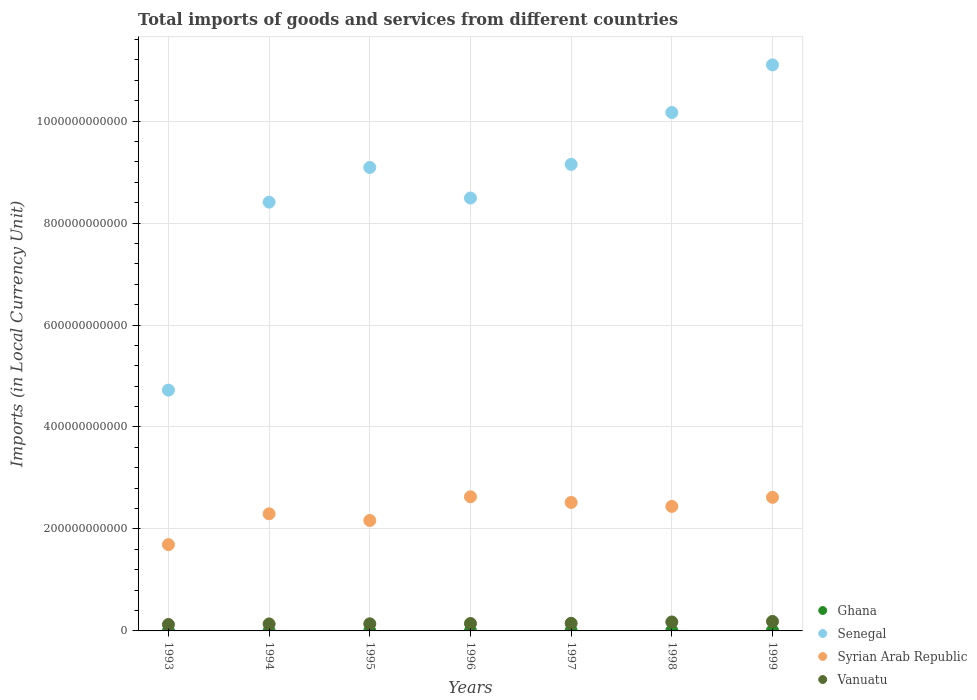Is the number of dotlines equal to the number of legend labels?
Your answer should be very brief. Yes. What is the Amount of goods and services imports in Ghana in 1998?
Provide a succinct answer. 8.08e+08. Across all years, what is the maximum Amount of goods and services imports in Ghana?
Offer a very short reply. 1.02e+09. Across all years, what is the minimum Amount of goods and services imports in Ghana?
Your response must be concise. 1.41e+08. In which year was the Amount of goods and services imports in Senegal maximum?
Your response must be concise. 1999. In which year was the Amount of goods and services imports in Vanuatu minimum?
Your answer should be compact. 1993. What is the total Amount of goods and services imports in Ghana in the graph?
Offer a very short reply. 3.62e+09. What is the difference between the Amount of goods and services imports in Vanuatu in 1994 and that in 1998?
Your answer should be very brief. -3.84e+09. What is the difference between the Amount of goods and services imports in Syrian Arab Republic in 1993 and the Amount of goods and services imports in Vanuatu in 1998?
Keep it short and to the point. 1.52e+11. What is the average Amount of goods and services imports in Syrian Arab Republic per year?
Offer a terse response. 2.34e+11. In the year 1996, what is the difference between the Amount of goods and services imports in Ghana and Amount of goods and services imports in Senegal?
Offer a very short reply. -8.49e+11. What is the ratio of the Amount of goods and services imports in Syrian Arab Republic in 1993 to that in 1997?
Provide a succinct answer. 0.67. What is the difference between the highest and the second highest Amount of goods and services imports in Ghana?
Keep it short and to the point. 2.13e+08. What is the difference between the highest and the lowest Amount of goods and services imports in Ghana?
Your answer should be compact. 8.80e+08. In how many years, is the Amount of goods and services imports in Ghana greater than the average Amount of goods and services imports in Ghana taken over all years?
Offer a terse response. 3. Is the sum of the Amount of goods and services imports in Vanuatu in 1993 and 1994 greater than the maximum Amount of goods and services imports in Senegal across all years?
Your answer should be compact. No. Is it the case that in every year, the sum of the Amount of goods and services imports in Syrian Arab Republic and Amount of goods and services imports in Vanuatu  is greater than the sum of Amount of goods and services imports in Senegal and Amount of goods and services imports in Ghana?
Offer a terse response. No. Does the Amount of goods and services imports in Ghana monotonically increase over the years?
Provide a succinct answer. Yes. Is the Amount of goods and services imports in Senegal strictly greater than the Amount of goods and services imports in Ghana over the years?
Provide a short and direct response. Yes. Is the Amount of goods and services imports in Ghana strictly less than the Amount of goods and services imports in Vanuatu over the years?
Provide a short and direct response. Yes. How many years are there in the graph?
Make the answer very short. 7. What is the difference between two consecutive major ticks on the Y-axis?
Your answer should be very brief. 2.00e+11. Does the graph contain grids?
Your answer should be very brief. Yes. How are the legend labels stacked?
Give a very brief answer. Vertical. What is the title of the graph?
Make the answer very short. Total imports of goods and services from different countries. Does "Congo (Democratic)" appear as one of the legend labels in the graph?
Your answer should be compact. No. What is the label or title of the X-axis?
Keep it short and to the point. Years. What is the label or title of the Y-axis?
Your answer should be very brief. Imports (in Local Currency Unit). What is the Imports (in Local Currency Unit) of Ghana in 1993?
Make the answer very short. 1.41e+08. What is the Imports (in Local Currency Unit) of Senegal in 1993?
Provide a short and direct response. 4.72e+11. What is the Imports (in Local Currency Unit) in Syrian Arab Republic in 1993?
Your response must be concise. 1.69e+11. What is the Imports (in Local Currency Unit) in Vanuatu in 1993?
Offer a very short reply. 1.26e+1. What is the Imports (in Local Currency Unit) in Ghana in 1994?
Ensure brevity in your answer.  1.91e+08. What is the Imports (in Local Currency Unit) of Senegal in 1994?
Give a very brief answer. 8.41e+11. What is the Imports (in Local Currency Unit) of Syrian Arab Republic in 1994?
Give a very brief answer. 2.30e+11. What is the Imports (in Local Currency Unit) of Vanuatu in 1994?
Give a very brief answer. 1.37e+1. What is the Imports (in Local Currency Unit) in Ghana in 1995?
Your answer should be very brief. 2.55e+08. What is the Imports (in Local Currency Unit) of Senegal in 1995?
Ensure brevity in your answer.  9.09e+11. What is the Imports (in Local Currency Unit) in Syrian Arab Republic in 1995?
Provide a succinct answer. 2.17e+11. What is the Imports (in Local Currency Unit) in Vanuatu in 1995?
Your response must be concise. 1.40e+1. What is the Imports (in Local Currency Unit) in Ghana in 1996?
Provide a short and direct response. 4.55e+08. What is the Imports (in Local Currency Unit) of Senegal in 1996?
Offer a terse response. 8.49e+11. What is the Imports (in Local Currency Unit) of Syrian Arab Republic in 1996?
Keep it short and to the point. 2.63e+11. What is the Imports (in Local Currency Unit) of Vanuatu in 1996?
Offer a terse response. 1.46e+1. What is the Imports (in Local Currency Unit) in Ghana in 1997?
Offer a very short reply. 7.48e+08. What is the Imports (in Local Currency Unit) of Senegal in 1997?
Provide a short and direct response. 9.15e+11. What is the Imports (in Local Currency Unit) in Syrian Arab Republic in 1997?
Your answer should be compact. 2.52e+11. What is the Imports (in Local Currency Unit) of Vanuatu in 1997?
Offer a very short reply. 1.49e+1. What is the Imports (in Local Currency Unit) in Ghana in 1998?
Offer a very short reply. 8.08e+08. What is the Imports (in Local Currency Unit) in Senegal in 1998?
Your answer should be very brief. 1.02e+12. What is the Imports (in Local Currency Unit) in Syrian Arab Republic in 1998?
Keep it short and to the point. 2.44e+11. What is the Imports (in Local Currency Unit) in Vanuatu in 1998?
Give a very brief answer. 1.75e+1. What is the Imports (in Local Currency Unit) of Ghana in 1999?
Give a very brief answer. 1.02e+09. What is the Imports (in Local Currency Unit) in Senegal in 1999?
Keep it short and to the point. 1.11e+12. What is the Imports (in Local Currency Unit) of Syrian Arab Republic in 1999?
Your answer should be compact. 2.62e+11. What is the Imports (in Local Currency Unit) of Vanuatu in 1999?
Your answer should be compact. 1.86e+1. Across all years, what is the maximum Imports (in Local Currency Unit) of Ghana?
Ensure brevity in your answer.  1.02e+09. Across all years, what is the maximum Imports (in Local Currency Unit) of Senegal?
Your response must be concise. 1.11e+12. Across all years, what is the maximum Imports (in Local Currency Unit) of Syrian Arab Republic?
Provide a succinct answer. 2.63e+11. Across all years, what is the maximum Imports (in Local Currency Unit) of Vanuatu?
Offer a terse response. 1.86e+1. Across all years, what is the minimum Imports (in Local Currency Unit) of Ghana?
Provide a short and direct response. 1.41e+08. Across all years, what is the minimum Imports (in Local Currency Unit) of Senegal?
Provide a succinct answer. 4.72e+11. Across all years, what is the minimum Imports (in Local Currency Unit) in Syrian Arab Republic?
Your response must be concise. 1.69e+11. Across all years, what is the minimum Imports (in Local Currency Unit) of Vanuatu?
Give a very brief answer. 1.26e+1. What is the total Imports (in Local Currency Unit) of Ghana in the graph?
Provide a short and direct response. 3.62e+09. What is the total Imports (in Local Currency Unit) in Senegal in the graph?
Ensure brevity in your answer.  6.11e+12. What is the total Imports (in Local Currency Unit) in Syrian Arab Republic in the graph?
Provide a short and direct response. 1.64e+12. What is the total Imports (in Local Currency Unit) in Vanuatu in the graph?
Give a very brief answer. 1.06e+11. What is the difference between the Imports (in Local Currency Unit) in Ghana in 1993 and that in 1994?
Provide a succinct answer. -5.03e+07. What is the difference between the Imports (in Local Currency Unit) in Senegal in 1993 and that in 1994?
Your answer should be very brief. -3.69e+11. What is the difference between the Imports (in Local Currency Unit) of Syrian Arab Republic in 1993 and that in 1994?
Offer a very short reply. -6.05e+1. What is the difference between the Imports (in Local Currency Unit) of Vanuatu in 1993 and that in 1994?
Your response must be concise. -1.07e+09. What is the difference between the Imports (in Local Currency Unit) in Ghana in 1993 and that in 1995?
Offer a very short reply. -1.14e+08. What is the difference between the Imports (in Local Currency Unit) in Senegal in 1993 and that in 1995?
Give a very brief answer. -4.37e+11. What is the difference between the Imports (in Local Currency Unit) of Syrian Arab Republic in 1993 and that in 1995?
Offer a very short reply. -4.74e+1. What is the difference between the Imports (in Local Currency Unit) of Vanuatu in 1993 and that in 1995?
Make the answer very short. -1.37e+09. What is the difference between the Imports (in Local Currency Unit) in Ghana in 1993 and that in 1996?
Make the answer very short. -3.14e+08. What is the difference between the Imports (in Local Currency Unit) in Senegal in 1993 and that in 1996?
Give a very brief answer. -3.77e+11. What is the difference between the Imports (in Local Currency Unit) in Syrian Arab Republic in 1993 and that in 1996?
Your response must be concise. -9.39e+1. What is the difference between the Imports (in Local Currency Unit) in Vanuatu in 1993 and that in 1996?
Ensure brevity in your answer.  -1.92e+09. What is the difference between the Imports (in Local Currency Unit) of Ghana in 1993 and that in 1997?
Your answer should be very brief. -6.07e+08. What is the difference between the Imports (in Local Currency Unit) of Senegal in 1993 and that in 1997?
Offer a terse response. -4.43e+11. What is the difference between the Imports (in Local Currency Unit) of Syrian Arab Republic in 1993 and that in 1997?
Ensure brevity in your answer.  -8.28e+1. What is the difference between the Imports (in Local Currency Unit) of Vanuatu in 1993 and that in 1997?
Your response must be concise. -2.31e+09. What is the difference between the Imports (in Local Currency Unit) in Ghana in 1993 and that in 1998?
Offer a very short reply. -6.67e+08. What is the difference between the Imports (in Local Currency Unit) of Senegal in 1993 and that in 1998?
Your answer should be very brief. -5.44e+11. What is the difference between the Imports (in Local Currency Unit) in Syrian Arab Republic in 1993 and that in 1998?
Your answer should be very brief. -7.50e+1. What is the difference between the Imports (in Local Currency Unit) of Vanuatu in 1993 and that in 1998?
Provide a succinct answer. -4.91e+09. What is the difference between the Imports (in Local Currency Unit) in Ghana in 1993 and that in 1999?
Give a very brief answer. -8.80e+08. What is the difference between the Imports (in Local Currency Unit) in Senegal in 1993 and that in 1999?
Ensure brevity in your answer.  -6.38e+11. What is the difference between the Imports (in Local Currency Unit) of Syrian Arab Republic in 1993 and that in 1999?
Give a very brief answer. -9.28e+1. What is the difference between the Imports (in Local Currency Unit) in Vanuatu in 1993 and that in 1999?
Your answer should be very brief. -6.00e+09. What is the difference between the Imports (in Local Currency Unit) in Ghana in 1994 and that in 1995?
Provide a succinct answer. -6.39e+07. What is the difference between the Imports (in Local Currency Unit) in Senegal in 1994 and that in 1995?
Offer a very short reply. -6.80e+1. What is the difference between the Imports (in Local Currency Unit) in Syrian Arab Republic in 1994 and that in 1995?
Provide a succinct answer. 1.31e+1. What is the difference between the Imports (in Local Currency Unit) in Vanuatu in 1994 and that in 1995?
Give a very brief answer. -2.99e+08. What is the difference between the Imports (in Local Currency Unit) in Ghana in 1994 and that in 1996?
Your answer should be very brief. -2.63e+08. What is the difference between the Imports (in Local Currency Unit) in Senegal in 1994 and that in 1996?
Ensure brevity in your answer.  -8.10e+09. What is the difference between the Imports (in Local Currency Unit) of Syrian Arab Republic in 1994 and that in 1996?
Make the answer very short. -3.34e+1. What is the difference between the Imports (in Local Currency Unit) of Vanuatu in 1994 and that in 1996?
Give a very brief answer. -8.51e+08. What is the difference between the Imports (in Local Currency Unit) in Ghana in 1994 and that in 1997?
Give a very brief answer. -5.57e+08. What is the difference between the Imports (in Local Currency Unit) of Senegal in 1994 and that in 1997?
Keep it short and to the point. -7.41e+1. What is the difference between the Imports (in Local Currency Unit) in Syrian Arab Republic in 1994 and that in 1997?
Provide a succinct answer. -2.23e+1. What is the difference between the Imports (in Local Currency Unit) of Vanuatu in 1994 and that in 1997?
Offer a terse response. -1.25e+09. What is the difference between the Imports (in Local Currency Unit) of Ghana in 1994 and that in 1998?
Your response must be concise. -6.17e+08. What is the difference between the Imports (in Local Currency Unit) of Senegal in 1994 and that in 1998?
Your answer should be compact. -1.76e+11. What is the difference between the Imports (in Local Currency Unit) in Syrian Arab Republic in 1994 and that in 1998?
Your answer should be very brief. -1.45e+1. What is the difference between the Imports (in Local Currency Unit) of Vanuatu in 1994 and that in 1998?
Make the answer very short. -3.84e+09. What is the difference between the Imports (in Local Currency Unit) in Ghana in 1994 and that in 1999?
Make the answer very short. -8.30e+08. What is the difference between the Imports (in Local Currency Unit) of Senegal in 1994 and that in 1999?
Make the answer very short. -2.69e+11. What is the difference between the Imports (in Local Currency Unit) of Syrian Arab Republic in 1994 and that in 1999?
Your answer should be very brief. -3.23e+1. What is the difference between the Imports (in Local Currency Unit) of Vanuatu in 1994 and that in 1999?
Provide a short and direct response. -4.93e+09. What is the difference between the Imports (in Local Currency Unit) in Ghana in 1995 and that in 1996?
Offer a very short reply. -1.99e+08. What is the difference between the Imports (in Local Currency Unit) in Senegal in 1995 and that in 1996?
Provide a short and direct response. 5.99e+1. What is the difference between the Imports (in Local Currency Unit) in Syrian Arab Republic in 1995 and that in 1996?
Keep it short and to the point. -4.65e+1. What is the difference between the Imports (in Local Currency Unit) of Vanuatu in 1995 and that in 1996?
Give a very brief answer. -5.52e+08. What is the difference between the Imports (in Local Currency Unit) in Ghana in 1995 and that in 1997?
Your answer should be very brief. -4.93e+08. What is the difference between the Imports (in Local Currency Unit) in Senegal in 1995 and that in 1997?
Provide a succinct answer. -6.03e+09. What is the difference between the Imports (in Local Currency Unit) of Syrian Arab Republic in 1995 and that in 1997?
Provide a succinct answer. -3.54e+1. What is the difference between the Imports (in Local Currency Unit) of Vanuatu in 1995 and that in 1997?
Keep it short and to the point. -9.47e+08. What is the difference between the Imports (in Local Currency Unit) of Ghana in 1995 and that in 1998?
Give a very brief answer. -5.53e+08. What is the difference between the Imports (in Local Currency Unit) in Senegal in 1995 and that in 1998?
Give a very brief answer. -1.08e+11. What is the difference between the Imports (in Local Currency Unit) of Syrian Arab Republic in 1995 and that in 1998?
Offer a very short reply. -2.76e+1. What is the difference between the Imports (in Local Currency Unit) of Vanuatu in 1995 and that in 1998?
Your answer should be compact. -3.54e+09. What is the difference between the Imports (in Local Currency Unit) in Ghana in 1995 and that in 1999?
Provide a short and direct response. -7.66e+08. What is the difference between the Imports (in Local Currency Unit) of Senegal in 1995 and that in 1999?
Offer a very short reply. -2.01e+11. What is the difference between the Imports (in Local Currency Unit) in Syrian Arab Republic in 1995 and that in 1999?
Make the answer very short. -4.54e+1. What is the difference between the Imports (in Local Currency Unit) in Vanuatu in 1995 and that in 1999?
Keep it short and to the point. -4.63e+09. What is the difference between the Imports (in Local Currency Unit) of Ghana in 1996 and that in 1997?
Make the answer very short. -2.93e+08. What is the difference between the Imports (in Local Currency Unit) in Senegal in 1996 and that in 1997?
Your answer should be very brief. -6.60e+1. What is the difference between the Imports (in Local Currency Unit) in Syrian Arab Republic in 1996 and that in 1997?
Provide a succinct answer. 1.11e+1. What is the difference between the Imports (in Local Currency Unit) in Vanuatu in 1996 and that in 1997?
Your response must be concise. -3.95e+08. What is the difference between the Imports (in Local Currency Unit) in Ghana in 1996 and that in 1998?
Offer a terse response. -3.54e+08. What is the difference between the Imports (in Local Currency Unit) in Senegal in 1996 and that in 1998?
Your answer should be compact. -1.68e+11. What is the difference between the Imports (in Local Currency Unit) of Syrian Arab Republic in 1996 and that in 1998?
Provide a short and direct response. 1.89e+1. What is the difference between the Imports (in Local Currency Unit) in Vanuatu in 1996 and that in 1998?
Offer a very short reply. -2.99e+09. What is the difference between the Imports (in Local Currency Unit) of Ghana in 1996 and that in 1999?
Give a very brief answer. -5.67e+08. What is the difference between the Imports (in Local Currency Unit) in Senegal in 1996 and that in 1999?
Your answer should be very brief. -2.61e+11. What is the difference between the Imports (in Local Currency Unit) of Syrian Arab Republic in 1996 and that in 1999?
Ensure brevity in your answer.  1.09e+09. What is the difference between the Imports (in Local Currency Unit) of Vanuatu in 1996 and that in 1999?
Make the answer very short. -4.08e+09. What is the difference between the Imports (in Local Currency Unit) in Ghana in 1997 and that in 1998?
Your answer should be very brief. -6.03e+07. What is the difference between the Imports (in Local Currency Unit) in Senegal in 1997 and that in 1998?
Keep it short and to the point. -1.02e+11. What is the difference between the Imports (in Local Currency Unit) in Syrian Arab Republic in 1997 and that in 1998?
Offer a very short reply. 7.81e+09. What is the difference between the Imports (in Local Currency Unit) in Vanuatu in 1997 and that in 1998?
Keep it short and to the point. -2.60e+09. What is the difference between the Imports (in Local Currency Unit) of Ghana in 1997 and that in 1999?
Offer a terse response. -2.73e+08. What is the difference between the Imports (in Local Currency Unit) of Senegal in 1997 and that in 1999?
Give a very brief answer. -1.95e+11. What is the difference between the Imports (in Local Currency Unit) in Syrian Arab Republic in 1997 and that in 1999?
Give a very brief answer. -1.00e+1. What is the difference between the Imports (in Local Currency Unit) of Vanuatu in 1997 and that in 1999?
Provide a short and direct response. -3.68e+09. What is the difference between the Imports (in Local Currency Unit) of Ghana in 1998 and that in 1999?
Offer a very short reply. -2.13e+08. What is the difference between the Imports (in Local Currency Unit) in Senegal in 1998 and that in 1999?
Ensure brevity in your answer.  -9.34e+1. What is the difference between the Imports (in Local Currency Unit) in Syrian Arab Republic in 1998 and that in 1999?
Provide a short and direct response. -1.78e+1. What is the difference between the Imports (in Local Currency Unit) of Vanuatu in 1998 and that in 1999?
Provide a short and direct response. -1.09e+09. What is the difference between the Imports (in Local Currency Unit) of Ghana in 1993 and the Imports (in Local Currency Unit) of Senegal in 1994?
Your answer should be very brief. -8.41e+11. What is the difference between the Imports (in Local Currency Unit) in Ghana in 1993 and the Imports (in Local Currency Unit) in Syrian Arab Republic in 1994?
Your answer should be very brief. -2.30e+11. What is the difference between the Imports (in Local Currency Unit) of Ghana in 1993 and the Imports (in Local Currency Unit) of Vanuatu in 1994?
Provide a succinct answer. -1.36e+1. What is the difference between the Imports (in Local Currency Unit) in Senegal in 1993 and the Imports (in Local Currency Unit) in Syrian Arab Republic in 1994?
Your answer should be compact. 2.43e+11. What is the difference between the Imports (in Local Currency Unit) in Senegal in 1993 and the Imports (in Local Currency Unit) in Vanuatu in 1994?
Give a very brief answer. 4.59e+11. What is the difference between the Imports (in Local Currency Unit) of Syrian Arab Republic in 1993 and the Imports (in Local Currency Unit) of Vanuatu in 1994?
Your answer should be compact. 1.56e+11. What is the difference between the Imports (in Local Currency Unit) in Ghana in 1993 and the Imports (in Local Currency Unit) in Senegal in 1995?
Your answer should be very brief. -9.09e+11. What is the difference between the Imports (in Local Currency Unit) of Ghana in 1993 and the Imports (in Local Currency Unit) of Syrian Arab Republic in 1995?
Keep it short and to the point. -2.16e+11. What is the difference between the Imports (in Local Currency Unit) of Ghana in 1993 and the Imports (in Local Currency Unit) of Vanuatu in 1995?
Provide a short and direct response. -1.39e+1. What is the difference between the Imports (in Local Currency Unit) in Senegal in 1993 and the Imports (in Local Currency Unit) in Syrian Arab Republic in 1995?
Offer a very short reply. 2.56e+11. What is the difference between the Imports (in Local Currency Unit) in Senegal in 1993 and the Imports (in Local Currency Unit) in Vanuatu in 1995?
Your answer should be compact. 4.58e+11. What is the difference between the Imports (in Local Currency Unit) of Syrian Arab Republic in 1993 and the Imports (in Local Currency Unit) of Vanuatu in 1995?
Offer a terse response. 1.55e+11. What is the difference between the Imports (in Local Currency Unit) of Ghana in 1993 and the Imports (in Local Currency Unit) of Senegal in 1996?
Your answer should be very brief. -8.49e+11. What is the difference between the Imports (in Local Currency Unit) of Ghana in 1993 and the Imports (in Local Currency Unit) of Syrian Arab Republic in 1996?
Provide a succinct answer. -2.63e+11. What is the difference between the Imports (in Local Currency Unit) in Ghana in 1993 and the Imports (in Local Currency Unit) in Vanuatu in 1996?
Keep it short and to the point. -1.44e+1. What is the difference between the Imports (in Local Currency Unit) of Senegal in 1993 and the Imports (in Local Currency Unit) of Syrian Arab Republic in 1996?
Provide a succinct answer. 2.09e+11. What is the difference between the Imports (in Local Currency Unit) of Senegal in 1993 and the Imports (in Local Currency Unit) of Vanuatu in 1996?
Offer a terse response. 4.58e+11. What is the difference between the Imports (in Local Currency Unit) in Syrian Arab Republic in 1993 and the Imports (in Local Currency Unit) in Vanuatu in 1996?
Give a very brief answer. 1.55e+11. What is the difference between the Imports (in Local Currency Unit) of Ghana in 1993 and the Imports (in Local Currency Unit) of Senegal in 1997?
Provide a succinct answer. -9.15e+11. What is the difference between the Imports (in Local Currency Unit) in Ghana in 1993 and the Imports (in Local Currency Unit) in Syrian Arab Republic in 1997?
Provide a short and direct response. -2.52e+11. What is the difference between the Imports (in Local Currency Unit) in Ghana in 1993 and the Imports (in Local Currency Unit) in Vanuatu in 1997?
Provide a succinct answer. -1.48e+1. What is the difference between the Imports (in Local Currency Unit) of Senegal in 1993 and the Imports (in Local Currency Unit) of Syrian Arab Republic in 1997?
Keep it short and to the point. 2.20e+11. What is the difference between the Imports (in Local Currency Unit) in Senegal in 1993 and the Imports (in Local Currency Unit) in Vanuatu in 1997?
Provide a succinct answer. 4.57e+11. What is the difference between the Imports (in Local Currency Unit) in Syrian Arab Republic in 1993 and the Imports (in Local Currency Unit) in Vanuatu in 1997?
Your answer should be very brief. 1.54e+11. What is the difference between the Imports (in Local Currency Unit) of Ghana in 1993 and the Imports (in Local Currency Unit) of Senegal in 1998?
Offer a terse response. -1.02e+12. What is the difference between the Imports (in Local Currency Unit) of Ghana in 1993 and the Imports (in Local Currency Unit) of Syrian Arab Republic in 1998?
Your answer should be compact. -2.44e+11. What is the difference between the Imports (in Local Currency Unit) in Ghana in 1993 and the Imports (in Local Currency Unit) in Vanuatu in 1998?
Ensure brevity in your answer.  -1.74e+1. What is the difference between the Imports (in Local Currency Unit) in Senegal in 1993 and the Imports (in Local Currency Unit) in Syrian Arab Republic in 1998?
Keep it short and to the point. 2.28e+11. What is the difference between the Imports (in Local Currency Unit) in Senegal in 1993 and the Imports (in Local Currency Unit) in Vanuatu in 1998?
Ensure brevity in your answer.  4.55e+11. What is the difference between the Imports (in Local Currency Unit) of Syrian Arab Republic in 1993 and the Imports (in Local Currency Unit) of Vanuatu in 1998?
Keep it short and to the point. 1.52e+11. What is the difference between the Imports (in Local Currency Unit) in Ghana in 1993 and the Imports (in Local Currency Unit) in Senegal in 1999?
Keep it short and to the point. -1.11e+12. What is the difference between the Imports (in Local Currency Unit) in Ghana in 1993 and the Imports (in Local Currency Unit) in Syrian Arab Republic in 1999?
Make the answer very short. -2.62e+11. What is the difference between the Imports (in Local Currency Unit) of Ghana in 1993 and the Imports (in Local Currency Unit) of Vanuatu in 1999?
Keep it short and to the point. -1.85e+1. What is the difference between the Imports (in Local Currency Unit) in Senegal in 1993 and the Imports (in Local Currency Unit) in Syrian Arab Republic in 1999?
Your answer should be compact. 2.10e+11. What is the difference between the Imports (in Local Currency Unit) in Senegal in 1993 and the Imports (in Local Currency Unit) in Vanuatu in 1999?
Offer a terse response. 4.54e+11. What is the difference between the Imports (in Local Currency Unit) in Syrian Arab Republic in 1993 and the Imports (in Local Currency Unit) in Vanuatu in 1999?
Keep it short and to the point. 1.51e+11. What is the difference between the Imports (in Local Currency Unit) in Ghana in 1994 and the Imports (in Local Currency Unit) in Senegal in 1995?
Give a very brief answer. -9.09e+11. What is the difference between the Imports (in Local Currency Unit) in Ghana in 1994 and the Imports (in Local Currency Unit) in Syrian Arab Republic in 1995?
Make the answer very short. -2.16e+11. What is the difference between the Imports (in Local Currency Unit) in Ghana in 1994 and the Imports (in Local Currency Unit) in Vanuatu in 1995?
Provide a succinct answer. -1.38e+1. What is the difference between the Imports (in Local Currency Unit) in Senegal in 1994 and the Imports (in Local Currency Unit) in Syrian Arab Republic in 1995?
Provide a short and direct response. 6.24e+11. What is the difference between the Imports (in Local Currency Unit) in Senegal in 1994 and the Imports (in Local Currency Unit) in Vanuatu in 1995?
Provide a succinct answer. 8.27e+11. What is the difference between the Imports (in Local Currency Unit) in Syrian Arab Republic in 1994 and the Imports (in Local Currency Unit) in Vanuatu in 1995?
Provide a succinct answer. 2.16e+11. What is the difference between the Imports (in Local Currency Unit) in Ghana in 1994 and the Imports (in Local Currency Unit) in Senegal in 1996?
Provide a succinct answer. -8.49e+11. What is the difference between the Imports (in Local Currency Unit) of Ghana in 1994 and the Imports (in Local Currency Unit) of Syrian Arab Republic in 1996?
Ensure brevity in your answer.  -2.63e+11. What is the difference between the Imports (in Local Currency Unit) in Ghana in 1994 and the Imports (in Local Currency Unit) in Vanuatu in 1996?
Provide a short and direct response. -1.44e+1. What is the difference between the Imports (in Local Currency Unit) of Senegal in 1994 and the Imports (in Local Currency Unit) of Syrian Arab Republic in 1996?
Keep it short and to the point. 5.78e+11. What is the difference between the Imports (in Local Currency Unit) in Senegal in 1994 and the Imports (in Local Currency Unit) in Vanuatu in 1996?
Provide a succinct answer. 8.26e+11. What is the difference between the Imports (in Local Currency Unit) of Syrian Arab Republic in 1994 and the Imports (in Local Currency Unit) of Vanuatu in 1996?
Provide a succinct answer. 2.15e+11. What is the difference between the Imports (in Local Currency Unit) of Ghana in 1994 and the Imports (in Local Currency Unit) of Senegal in 1997?
Your answer should be compact. -9.15e+11. What is the difference between the Imports (in Local Currency Unit) in Ghana in 1994 and the Imports (in Local Currency Unit) in Syrian Arab Republic in 1997?
Provide a short and direct response. -2.52e+11. What is the difference between the Imports (in Local Currency Unit) of Ghana in 1994 and the Imports (in Local Currency Unit) of Vanuatu in 1997?
Offer a very short reply. -1.48e+1. What is the difference between the Imports (in Local Currency Unit) of Senegal in 1994 and the Imports (in Local Currency Unit) of Syrian Arab Republic in 1997?
Give a very brief answer. 5.89e+11. What is the difference between the Imports (in Local Currency Unit) in Senegal in 1994 and the Imports (in Local Currency Unit) in Vanuatu in 1997?
Make the answer very short. 8.26e+11. What is the difference between the Imports (in Local Currency Unit) in Syrian Arab Republic in 1994 and the Imports (in Local Currency Unit) in Vanuatu in 1997?
Provide a short and direct response. 2.15e+11. What is the difference between the Imports (in Local Currency Unit) of Ghana in 1994 and the Imports (in Local Currency Unit) of Senegal in 1998?
Ensure brevity in your answer.  -1.02e+12. What is the difference between the Imports (in Local Currency Unit) in Ghana in 1994 and the Imports (in Local Currency Unit) in Syrian Arab Republic in 1998?
Keep it short and to the point. -2.44e+11. What is the difference between the Imports (in Local Currency Unit) in Ghana in 1994 and the Imports (in Local Currency Unit) in Vanuatu in 1998?
Your response must be concise. -1.74e+1. What is the difference between the Imports (in Local Currency Unit) of Senegal in 1994 and the Imports (in Local Currency Unit) of Syrian Arab Republic in 1998?
Provide a short and direct response. 5.97e+11. What is the difference between the Imports (in Local Currency Unit) of Senegal in 1994 and the Imports (in Local Currency Unit) of Vanuatu in 1998?
Give a very brief answer. 8.23e+11. What is the difference between the Imports (in Local Currency Unit) of Syrian Arab Republic in 1994 and the Imports (in Local Currency Unit) of Vanuatu in 1998?
Your answer should be compact. 2.12e+11. What is the difference between the Imports (in Local Currency Unit) in Ghana in 1994 and the Imports (in Local Currency Unit) in Senegal in 1999?
Offer a very short reply. -1.11e+12. What is the difference between the Imports (in Local Currency Unit) in Ghana in 1994 and the Imports (in Local Currency Unit) in Syrian Arab Republic in 1999?
Offer a terse response. -2.62e+11. What is the difference between the Imports (in Local Currency Unit) of Ghana in 1994 and the Imports (in Local Currency Unit) of Vanuatu in 1999?
Make the answer very short. -1.84e+1. What is the difference between the Imports (in Local Currency Unit) of Senegal in 1994 and the Imports (in Local Currency Unit) of Syrian Arab Republic in 1999?
Ensure brevity in your answer.  5.79e+11. What is the difference between the Imports (in Local Currency Unit) of Senegal in 1994 and the Imports (in Local Currency Unit) of Vanuatu in 1999?
Your answer should be very brief. 8.22e+11. What is the difference between the Imports (in Local Currency Unit) of Syrian Arab Republic in 1994 and the Imports (in Local Currency Unit) of Vanuatu in 1999?
Provide a short and direct response. 2.11e+11. What is the difference between the Imports (in Local Currency Unit) of Ghana in 1995 and the Imports (in Local Currency Unit) of Senegal in 1996?
Your answer should be very brief. -8.49e+11. What is the difference between the Imports (in Local Currency Unit) in Ghana in 1995 and the Imports (in Local Currency Unit) in Syrian Arab Republic in 1996?
Your response must be concise. -2.63e+11. What is the difference between the Imports (in Local Currency Unit) of Ghana in 1995 and the Imports (in Local Currency Unit) of Vanuatu in 1996?
Ensure brevity in your answer.  -1.43e+1. What is the difference between the Imports (in Local Currency Unit) in Senegal in 1995 and the Imports (in Local Currency Unit) in Syrian Arab Republic in 1996?
Make the answer very short. 6.46e+11. What is the difference between the Imports (in Local Currency Unit) of Senegal in 1995 and the Imports (in Local Currency Unit) of Vanuatu in 1996?
Your response must be concise. 8.94e+11. What is the difference between the Imports (in Local Currency Unit) of Syrian Arab Republic in 1995 and the Imports (in Local Currency Unit) of Vanuatu in 1996?
Make the answer very short. 2.02e+11. What is the difference between the Imports (in Local Currency Unit) of Ghana in 1995 and the Imports (in Local Currency Unit) of Senegal in 1997?
Give a very brief answer. -9.15e+11. What is the difference between the Imports (in Local Currency Unit) of Ghana in 1995 and the Imports (in Local Currency Unit) of Syrian Arab Republic in 1997?
Your response must be concise. -2.52e+11. What is the difference between the Imports (in Local Currency Unit) in Ghana in 1995 and the Imports (in Local Currency Unit) in Vanuatu in 1997?
Provide a succinct answer. -1.47e+1. What is the difference between the Imports (in Local Currency Unit) in Senegal in 1995 and the Imports (in Local Currency Unit) in Syrian Arab Republic in 1997?
Provide a succinct answer. 6.57e+11. What is the difference between the Imports (in Local Currency Unit) of Senegal in 1995 and the Imports (in Local Currency Unit) of Vanuatu in 1997?
Your answer should be compact. 8.94e+11. What is the difference between the Imports (in Local Currency Unit) of Syrian Arab Republic in 1995 and the Imports (in Local Currency Unit) of Vanuatu in 1997?
Provide a succinct answer. 2.02e+11. What is the difference between the Imports (in Local Currency Unit) of Ghana in 1995 and the Imports (in Local Currency Unit) of Senegal in 1998?
Provide a succinct answer. -1.02e+12. What is the difference between the Imports (in Local Currency Unit) of Ghana in 1995 and the Imports (in Local Currency Unit) of Syrian Arab Republic in 1998?
Provide a succinct answer. -2.44e+11. What is the difference between the Imports (in Local Currency Unit) in Ghana in 1995 and the Imports (in Local Currency Unit) in Vanuatu in 1998?
Provide a succinct answer. -1.73e+1. What is the difference between the Imports (in Local Currency Unit) of Senegal in 1995 and the Imports (in Local Currency Unit) of Syrian Arab Republic in 1998?
Your answer should be compact. 6.65e+11. What is the difference between the Imports (in Local Currency Unit) of Senegal in 1995 and the Imports (in Local Currency Unit) of Vanuatu in 1998?
Give a very brief answer. 8.91e+11. What is the difference between the Imports (in Local Currency Unit) in Syrian Arab Republic in 1995 and the Imports (in Local Currency Unit) in Vanuatu in 1998?
Keep it short and to the point. 1.99e+11. What is the difference between the Imports (in Local Currency Unit) of Ghana in 1995 and the Imports (in Local Currency Unit) of Senegal in 1999?
Offer a very short reply. -1.11e+12. What is the difference between the Imports (in Local Currency Unit) of Ghana in 1995 and the Imports (in Local Currency Unit) of Syrian Arab Republic in 1999?
Offer a terse response. -2.62e+11. What is the difference between the Imports (in Local Currency Unit) in Ghana in 1995 and the Imports (in Local Currency Unit) in Vanuatu in 1999?
Provide a short and direct response. -1.84e+1. What is the difference between the Imports (in Local Currency Unit) in Senegal in 1995 and the Imports (in Local Currency Unit) in Syrian Arab Republic in 1999?
Provide a succinct answer. 6.47e+11. What is the difference between the Imports (in Local Currency Unit) in Senegal in 1995 and the Imports (in Local Currency Unit) in Vanuatu in 1999?
Your response must be concise. 8.90e+11. What is the difference between the Imports (in Local Currency Unit) in Syrian Arab Republic in 1995 and the Imports (in Local Currency Unit) in Vanuatu in 1999?
Give a very brief answer. 1.98e+11. What is the difference between the Imports (in Local Currency Unit) in Ghana in 1996 and the Imports (in Local Currency Unit) in Senegal in 1997?
Give a very brief answer. -9.15e+11. What is the difference between the Imports (in Local Currency Unit) in Ghana in 1996 and the Imports (in Local Currency Unit) in Syrian Arab Republic in 1997?
Your response must be concise. -2.52e+11. What is the difference between the Imports (in Local Currency Unit) of Ghana in 1996 and the Imports (in Local Currency Unit) of Vanuatu in 1997?
Your answer should be very brief. -1.45e+1. What is the difference between the Imports (in Local Currency Unit) of Senegal in 1996 and the Imports (in Local Currency Unit) of Syrian Arab Republic in 1997?
Provide a short and direct response. 5.97e+11. What is the difference between the Imports (in Local Currency Unit) of Senegal in 1996 and the Imports (in Local Currency Unit) of Vanuatu in 1997?
Your response must be concise. 8.34e+11. What is the difference between the Imports (in Local Currency Unit) in Syrian Arab Republic in 1996 and the Imports (in Local Currency Unit) in Vanuatu in 1997?
Make the answer very short. 2.48e+11. What is the difference between the Imports (in Local Currency Unit) in Ghana in 1996 and the Imports (in Local Currency Unit) in Senegal in 1998?
Provide a short and direct response. -1.02e+12. What is the difference between the Imports (in Local Currency Unit) of Ghana in 1996 and the Imports (in Local Currency Unit) of Syrian Arab Republic in 1998?
Provide a short and direct response. -2.44e+11. What is the difference between the Imports (in Local Currency Unit) of Ghana in 1996 and the Imports (in Local Currency Unit) of Vanuatu in 1998?
Make the answer very short. -1.71e+1. What is the difference between the Imports (in Local Currency Unit) in Senegal in 1996 and the Imports (in Local Currency Unit) in Syrian Arab Republic in 1998?
Give a very brief answer. 6.05e+11. What is the difference between the Imports (in Local Currency Unit) in Senegal in 1996 and the Imports (in Local Currency Unit) in Vanuatu in 1998?
Offer a terse response. 8.32e+11. What is the difference between the Imports (in Local Currency Unit) in Syrian Arab Republic in 1996 and the Imports (in Local Currency Unit) in Vanuatu in 1998?
Ensure brevity in your answer.  2.46e+11. What is the difference between the Imports (in Local Currency Unit) of Ghana in 1996 and the Imports (in Local Currency Unit) of Senegal in 1999?
Your answer should be very brief. -1.11e+12. What is the difference between the Imports (in Local Currency Unit) in Ghana in 1996 and the Imports (in Local Currency Unit) in Syrian Arab Republic in 1999?
Make the answer very short. -2.62e+11. What is the difference between the Imports (in Local Currency Unit) of Ghana in 1996 and the Imports (in Local Currency Unit) of Vanuatu in 1999?
Offer a very short reply. -1.82e+1. What is the difference between the Imports (in Local Currency Unit) of Senegal in 1996 and the Imports (in Local Currency Unit) of Syrian Arab Republic in 1999?
Offer a terse response. 5.87e+11. What is the difference between the Imports (in Local Currency Unit) of Senegal in 1996 and the Imports (in Local Currency Unit) of Vanuatu in 1999?
Ensure brevity in your answer.  8.30e+11. What is the difference between the Imports (in Local Currency Unit) in Syrian Arab Republic in 1996 and the Imports (in Local Currency Unit) in Vanuatu in 1999?
Make the answer very short. 2.45e+11. What is the difference between the Imports (in Local Currency Unit) in Ghana in 1997 and the Imports (in Local Currency Unit) in Senegal in 1998?
Keep it short and to the point. -1.02e+12. What is the difference between the Imports (in Local Currency Unit) in Ghana in 1997 and the Imports (in Local Currency Unit) in Syrian Arab Republic in 1998?
Give a very brief answer. -2.43e+11. What is the difference between the Imports (in Local Currency Unit) in Ghana in 1997 and the Imports (in Local Currency Unit) in Vanuatu in 1998?
Keep it short and to the point. -1.68e+1. What is the difference between the Imports (in Local Currency Unit) of Senegal in 1997 and the Imports (in Local Currency Unit) of Syrian Arab Republic in 1998?
Ensure brevity in your answer.  6.71e+11. What is the difference between the Imports (in Local Currency Unit) of Senegal in 1997 and the Imports (in Local Currency Unit) of Vanuatu in 1998?
Offer a very short reply. 8.97e+11. What is the difference between the Imports (in Local Currency Unit) in Syrian Arab Republic in 1997 and the Imports (in Local Currency Unit) in Vanuatu in 1998?
Your answer should be compact. 2.34e+11. What is the difference between the Imports (in Local Currency Unit) in Ghana in 1997 and the Imports (in Local Currency Unit) in Senegal in 1999?
Provide a succinct answer. -1.11e+12. What is the difference between the Imports (in Local Currency Unit) in Ghana in 1997 and the Imports (in Local Currency Unit) in Syrian Arab Republic in 1999?
Ensure brevity in your answer.  -2.61e+11. What is the difference between the Imports (in Local Currency Unit) of Ghana in 1997 and the Imports (in Local Currency Unit) of Vanuatu in 1999?
Offer a terse response. -1.79e+1. What is the difference between the Imports (in Local Currency Unit) in Senegal in 1997 and the Imports (in Local Currency Unit) in Syrian Arab Republic in 1999?
Offer a terse response. 6.53e+11. What is the difference between the Imports (in Local Currency Unit) in Senegal in 1997 and the Imports (in Local Currency Unit) in Vanuatu in 1999?
Give a very brief answer. 8.96e+11. What is the difference between the Imports (in Local Currency Unit) in Syrian Arab Republic in 1997 and the Imports (in Local Currency Unit) in Vanuatu in 1999?
Give a very brief answer. 2.33e+11. What is the difference between the Imports (in Local Currency Unit) in Ghana in 1998 and the Imports (in Local Currency Unit) in Senegal in 1999?
Offer a terse response. -1.11e+12. What is the difference between the Imports (in Local Currency Unit) of Ghana in 1998 and the Imports (in Local Currency Unit) of Syrian Arab Republic in 1999?
Offer a terse response. -2.61e+11. What is the difference between the Imports (in Local Currency Unit) in Ghana in 1998 and the Imports (in Local Currency Unit) in Vanuatu in 1999?
Offer a very short reply. -1.78e+1. What is the difference between the Imports (in Local Currency Unit) in Senegal in 1998 and the Imports (in Local Currency Unit) in Syrian Arab Republic in 1999?
Offer a very short reply. 7.55e+11. What is the difference between the Imports (in Local Currency Unit) in Senegal in 1998 and the Imports (in Local Currency Unit) in Vanuatu in 1999?
Give a very brief answer. 9.98e+11. What is the difference between the Imports (in Local Currency Unit) in Syrian Arab Republic in 1998 and the Imports (in Local Currency Unit) in Vanuatu in 1999?
Offer a terse response. 2.26e+11. What is the average Imports (in Local Currency Unit) of Ghana per year?
Your answer should be compact. 5.17e+08. What is the average Imports (in Local Currency Unit) of Senegal per year?
Make the answer very short. 8.73e+11. What is the average Imports (in Local Currency Unit) in Syrian Arab Republic per year?
Your answer should be compact. 2.34e+11. What is the average Imports (in Local Currency Unit) in Vanuatu per year?
Give a very brief answer. 1.51e+1. In the year 1993, what is the difference between the Imports (in Local Currency Unit) in Ghana and Imports (in Local Currency Unit) in Senegal?
Offer a terse response. -4.72e+11. In the year 1993, what is the difference between the Imports (in Local Currency Unit) in Ghana and Imports (in Local Currency Unit) in Syrian Arab Republic?
Give a very brief answer. -1.69e+11. In the year 1993, what is the difference between the Imports (in Local Currency Unit) in Ghana and Imports (in Local Currency Unit) in Vanuatu?
Offer a terse response. -1.25e+1. In the year 1993, what is the difference between the Imports (in Local Currency Unit) in Senegal and Imports (in Local Currency Unit) in Syrian Arab Republic?
Your response must be concise. 3.03e+11. In the year 1993, what is the difference between the Imports (in Local Currency Unit) in Senegal and Imports (in Local Currency Unit) in Vanuatu?
Make the answer very short. 4.60e+11. In the year 1993, what is the difference between the Imports (in Local Currency Unit) of Syrian Arab Republic and Imports (in Local Currency Unit) of Vanuatu?
Keep it short and to the point. 1.57e+11. In the year 1994, what is the difference between the Imports (in Local Currency Unit) of Ghana and Imports (in Local Currency Unit) of Senegal?
Keep it short and to the point. -8.41e+11. In the year 1994, what is the difference between the Imports (in Local Currency Unit) in Ghana and Imports (in Local Currency Unit) in Syrian Arab Republic?
Your answer should be very brief. -2.30e+11. In the year 1994, what is the difference between the Imports (in Local Currency Unit) of Ghana and Imports (in Local Currency Unit) of Vanuatu?
Offer a terse response. -1.35e+1. In the year 1994, what is the difference between the Imports (in Local Currency Unit) of Senegal and Imports (in Local Currency Unit) of Syrian Arab Republic?
Provide a short and direct response. 6.11e+11. In the year 1994, what is the difference between the Imports (in Local Currency Unit) of Senegal and Imports (in Local Currency Unit) of Vanuatu?
Provide a short and direct response. 8.27e+11. In the year 1994, what is the difference between the Imports (in Local Currency Unit) in Syrian Arab Republic and Imports (in Local Currency Unit) in Vanuatu?
Ensure brevity in your answer.  2.16e+11. In the year 1995, what is the difference between the Imports (in Local Currency Unit) of Ghana and Imports (in Local Currency Unit) of Senegal?
Offer a very short reply. -9.09e+11. In the year 1995, what is the difference between the Imports (in Local Currency Unit) of Ghana and Imports (in Local Currency Unit) of Syrian Arab Republic?
Offer a very short reply. -2.16e+11. In the year 1995, what is the difference between the Imports (in Local Currency Unit) of Ghana and Imports (in Local Currency Unit) of Vanuatu?
Your answer should be very brief. -1.37e+1. In the year 1995, what is the difference between the Imports (in Local Currency Unit) in Senegal and Imports (in Local Currency Unit) in Syrian Arab Republic?
Offer a terse response. 6.92e+11. In the year 1995, what is the difference between the Imports (in Local Currency Unit) in Senegal and Imports (in Local Currency Unit) in Vanuatu?
Make the answer very short. 8.95e+11. In the year 1995, what is the difference between the Imports (in Local Currency Unit) of Syrian Arab Republic and Imports (in Local Currency Unit) of Vanuatu?
Your answer should be compact. 2.03e+11. In the year 1996, what is the difference between the Imports (in Local Currency Unit) of Ghana and Imports (in Local Currency Unit) of Senegal?
Your answer should be very brief. -8.49e+11. In the year 1996, what is the difference between the Imports (in Local Currency Unit) of Ghana and Imports (in Local Currency Unit) of Syrian Arab Republic?
Your answer should be compact. -2.63e+11. In the year 1996, what is the difference between the Imports (in Local Currency Unit) in Ghana and Imports (in Local Currency Unit) in Vanuatu?
Your answer should be very brief. -1.41e+1. In the year 1996, what is the difference between the Imports (in Local Currency Unit) in Senegal and Imports (in Local Currency Unit) in Syrian Arab Republic?
Your response must be concise. 5.86e+11. In the year 1996, what is the difference between the Imports (in Local Currency Unit) in Senegal and Imports (in Local Currency Unit) in Vanuatu?
Provide a succinct answer. 8.35e+11. In the year 1996, what is the difference between the Imports (in Local Currency Unit) in Syrian Arab Republic and Imports (in Local Currency Unit) in Vanuatu?
Make the answer very short. 2.49e+11. In the year 1997, what is the difference between the Imports (in Local Currency Unit) of Ghana and Imports (in Local Currency Unit) of Senegal?
Ensure brevity in your answer.  -9.14e+11. In the year 1997, what is the difference between the Imports (in Local Currency Unit) in Ghana and Imports (in Local Currency Unit) in Syrian Arab Republic?
Keep it short and to the point. -2.51e+11. In the year 1997, what is the difference between the Imports (in Local Currency Unit) of Ghana and Imports (in Local Currency Unit) of Vanuatu?
Provide a short and direct response. -1.42e+1. In the year 1997, what is the difference between the Imports (in Local Currency Unit) in Senegal and Imports (in Local Currency Unit) in Syrian Arab Republic?
Keep it short and to the point. 6.63e+11. In the year 1997, what is the difference between the Imports (in Local Currency Unit) of Senegal and Imports (in Local Currency Unit) of Vanuatu?
Offer a very short reply. 9.00e+11. In the year 1997, what is the difference between the Imports (in Local Currency Unit) in Syrian Arab Republic and Imports (in Local Currency Unit) in Vanuatu?
Offer a very short reply. 2.37e+11. In the year 1998, what is the difference between the Imports (in Local Currency Unit) in Ghana and Imports (in Local Currency Unit) in Senegal?
Provide a succinct answer. -1.02e+12. In the year 1998, what is the difference between the Imports (in Local Currency Unit) in Ghana and Imports (in Local Currency Unit) in Syrian Arab Republic?
Offer a terse response. -2.43e+11. In the year 1998, what is the difference between the Imports (in Local Currency Unit) of Ghana and Imports (in Local Currency Unit) of Vanuatu?
Ensure brevity in your answer.  -1.67e+1. In the year 1998, what is the difference between the Imports (in Local Currency Unit) in Senegal and Imports (in Local Currency Unit) in Syrian Arab Republic?
Your answer should be compact. 7.73e+11. In the year 1998, what is the difference between the Imports (in Local Currency Unit) of Senegal and Imports (in Local Currency Unit) of Vanuatu?
Offer a very short reply. 9.99e+11. In the year 1998, what is the difference between the Imports (in Local Currency Unit) of Syrian Arab Republic and Imports (in Local Currency Unit) of Vanuatu?
Your response must be concise. 2.27e+11. In the year 1999, what is the difference between the Imports (in Local Currency Unit) of Ghana and Imports (in Local Currency Unit) of Senegal?
Offer a very short reply. -1.11e+12. In the year 1999, what is the difference between the Imports (in Local Currency Unit) of Ghana and Imports (in Local Currency Unit) of Syrian Arab Republic?
Offer a terse response. -2.61e+11. In the year 1999, what is the difference between the Imports (in Local Currency Unit) in Ghana and Imports (in Local Currency Unit) in Vanuatu?
Make the answer very short. -1.76e+1. In the year 1999, what is the difference between the Imports (in Local Currency Unit) of Senegal and Imports (in Local Currency Unit) of Syrian Arab Republic?
Ensure brevity in your answer.  8.48e+11. In the year 1999, what is the difference between the Imports (in Local Currency Unit) in Senegal and Imports (in Local Currency Unit) in Vanuatu?
Offer a very short reply. 1.09e+12. In the year 1999, what is the difference between the Imports (in Local Currency Unit) in Syrian Arab Republic and Imports (in Local Currency Unit) in Vanuatu?
Ensure brevity in your answer.  2.43e+11. What is the ratio of the Imports (in Local Currency Unit) of Ghana in 1993 to that in 1994?
Make the answer very short. 0.74. What is the ratio of the Imports (in Local Currency Unit) in Senegal in 1993 to that in 1994?
Offer a very short reply. 0.56. What is the ratio of the Imports (in Local Currency Unit) of Syrian Arab Republic in 1993 to that in 1994?
Give a very brief answer. 0.74. What is the ratio of the Imports (in Local Currency Unit) of Vanuatu in 1993 to that in 1994?
Provide a short and direct response. 0.92. What is the ratio of the Imports (in Local Currency Unit) of Ghana in 1993 to that in 1995?
Give a very brief answer. 0.55. What is the ratio of the Imports (in Local Currency Unit) in Senegal in 1993 to that in 1995?
Your answer should be compact. 0.52. What is the ratio of the Imports (in Local Currency Unit) of Syrian Arab Republic in 1993 to that in 1995?
Provide a succinct answer. 0.78. What is the ratio of the Imports (in Local Currency Unit) in Vanuatu in 1993 to that in 1995?
Your response must be concise. 0.9. What is the ratio of the Imports (in Local Currency Unit) in Ghana in 1993 to that in 1996?
Your answer should be very brief. 0.31. What is the ratio of the Imports (in Local Currency Unit) in Senegal in 1993 to that in 1996?
Offer a terse response. 0.56. What is the ratio of the Imports (in Local Currency Unit) in Syrian Arab Republic in 1993 to that in 1996?
Keep it short and to the point. 0.64. What is the ratio of the Imports (in Local Currency Unit) of Vanuatu in 1993 to that in 1996?
Provide a short and direct response. 0.87. What is the ratio of the Imports (in Local Currency Unit) in Ghana in 1993 to that in 1997?
Offer a terse response. 0.19. What is the ratio of the Imports (in Local Currency Unit) of Senegal in 1993 to that in 1997?
Keep it short and to the point. 0.52. What is the ratio of the Imports (in Local Currency Unit) in Syrian Arab Republic in 1993 to that in 1997?
Offer a very short reply. 0.67. What is the ratio of the Imports (in Local Currency Unit) of Vanuatu in 1993 to that in 1997?
Your response must be concise. 0.85. What is the ratio of the Imports (in Local Currency Unit) of Ghana in 1993 to that in 1998?
Give a very brief answer. 0.17. What is the ratio of the Imports (in Local Currency Unit) of Senegal in 1993 to that in 1998?
Provide a short and direct response. 0.46. What is the ratio of the Imports (in Local Currency Unit) of Syrian Arab Republic in 1993 to that in 1998?
Provide a short and direct response. 0.69. What is the ratio of the Imports (in Local Currency Unit) of Vanuatu in 1993 to that in 1998?
Your answer should be very brief. 0.72. What is the ratio of the Imports (in Local Currency Unit) in Ghana in 1993 to that in 1999?
Ensure brevity in your answer.  0.14. What is the ratio of the Imports (in Local Currency Unit) in Senegal in 1993 to that in 1999?
Offer a terse response. 0.43. What is the ratio of the Imports (in Local Currency Unit) of Syrian Arab Republic in 1993 to that in 1999?
Give a very brief answer. 0.65. What is the ratio of the Imports (in Local Currency Unit) in Vanuatu in 1993 to that in 1999?
Give a very brief answer. 0.68. What is the ratio of the Imports (in Local Currency Unit) of Ghana in 1994 to that in 1995?
Your answer should be compact. 0.75. What is the ratio of the Imports (in Local Currency Unit) in Senegal in 1994 to that in 1995?
Provide a succinct answer. 0.93. What is the ratio of the Imports (in Local Currency Unit) in Syrian Arab Republic in 1994 to that in 1995?
Your response must be concise. 1.06. What is the ratio of the Imports (in Local Currency Unit) in Vanuatu in 1994 to that in 1995?
Make the answer very short. 0.98. What is the ratio of the Imports (in Local Currency Unit) in Ghana in 1994 to that in 1996?
Your answer should be very brief. 0.42. What is the ratio of the Imports (in Local Currency Unit) in Senegal in 1994 to that in 1996?
Offer a very short reply. 0.99. What is the ratio of the Imports (in Local Currency Unit) of Syrian Arab Republic in 1994 to that in 1996?
Your answer should be very brief. 0.87. What is the ratio of the Imports (in Local Currency Unit) in Vanuatu in 1994 to that in 1996?
Your response must be concise. 0.94. What is the ratio of the Imports (in Local Currency Unit) in Ghana in 1994 to that in 1997?
Your response must be concise. 0.26. What is the ratio of the Imports (in Local Currency Unit) in Senegal in 1994 to that in 1997?
Your response must be concise. 0.92. What is the ratio of the Imports (in Local Currency Unit) in Syrian Arab Republic in 1994 to that in 1997?
Make the answer very short. 0.91. What is the ratio of the Imports (in Local Currency Unit) in Vanuatu in 1994 to that in 1997?
Ensure brevity in your answer.  0.92. What is the ratio of the Imports (in Local Currency Unit) in Ghana in 1994 to that in 1998?
Your response must be concise. 0.24. What is the ratio of the Imports (in Local Currency Unit) of Senegal in 1994 to that in 1998?
Give a very brief answer. 0.83. What is the ratio of the Imports (in Local Currency Unit) in Syrian Arab Republic in 1994 to that in 1998?
Offer a terse response. 0.94. What is the ratio of the Imports (in Local Currency Unit) of Vanuatu in 1994 to that in 1998?
Keep it short and to the point. 0.78. What is the ratio of the Imports (in Local Currency Unit) in Ghana in 1994 to that in 1999?
Give a very brief answer. 0.19. What is the ratio of the Imports (in Local Currency Unit) of Senegal in 1994 to that in 1999?
Provide a succinct answer. 0.76. What is the ratio of the Imports (in Local Currency Unit) in Syrian Arab Republic in 1994 to that in 1999?
Your response must be concise. 0.88. What is the ratio of the Imports (in Local Currency Unit) in Vanuatu in 1994 to that in 1999?
Your answer should be compact. 0.74. What is the ratio of the Imports (in Local Currency Unit) in Ghana in 1995 to that in 1996?
Your answer should be compact. 0.56. What is the ratio of the Imports (in Local Currency Unit) in Senegal in 1995 to that in 1996?
Your answer should be very brief. 1.07. What is the ratio of the Imports (in Local Currency Unit) in Syrian Arab Republic in 1995 to that in 1996?
Keep it short and to the point. 0.82. What is the ratio of the Imports (in Local Currency Unit) in Vanuatu in 1995 to that in 1996?
Keep it short and to the point. 0.96. What is the ratio of the Imports (in Local Currency Unit) in Ghana in 1995 to that in 1997?
Give a very brief answer. 0.34. What is the ratio of the Imports (in Local Currency Unit) of Senegal in 1995 to that in 1997?
Make the answer very short. 0.99. What is the ratio of the Imports (in Local Currency Unit) in Syrian Arab Republic in 1995 to that in 1997?
Offer a terse response. 0.86. What is the ratio of the Imports (in Local Currency Unit) in Vanuatu in 1995 to that in 1997?
Your answer should be compact. 0.94. What is the ratio of the Imports (in Local Currency Unit) of Ghana in 1995 to that in 1998?
Your answer should be very brief. 0.32. What is the ratio of the Imports (in Local Currency Unit) of Senegal in 1995 to that in 1998?
Your answer should be very brief. 0.89. What is the ratio of the Imports (in Local Currency Unit) of Syrian Arab Republic in 1995 to that in 1998?
Provide a succinct answer. 0.89. What is the ratio of the Imports (in Local Currency Unit) of Vanuatu in 1995 to that in 1998?
Offer a terse response. 0.8. What is the ratio of the Imports (in Local Currency Unit) of Ghana in 1995 to that in 1999?
Give a very brief answer. 0.25. What is the ratio of the Imports (in Local Currency Unit) in Senegal in 1995 to that in 1999?
Provide a succinct answer. 0.82. What is the ratio of the Imports (in Local Currency Unit) of Syrian Arab Republic in 1995 to that in 1999?
Your answer should be very brief. 0.83. What is the ratio of the Imports (in Local Currency Unit) of Vanuatu in 1995 to that in 1999?
Your answer should be compact. 0.75. What is the ratio of the Imports (in Local Currency Unit) in Ghana in 1996 to that in 1997?
Provide a short and direct response. 0.61. What is the ratio of the Imports (in Local Currency Unit) of Senegal in 1996 to that in 1997?
Provide a succinct answer. 0.93. What is the ratio of the Imports (in Local Currency Unit) in Syrian Arab Republic in 1996 to that in 1997?
Provide a succinct answer. 1.04. What is the ratio of the Imports (in Local Currency Unit) of Vanuatu in 1996 to that in 1997?
Keep it short and to the point. 0.97. What is the ratio of the Imports (in Local Currency Unit) in Ghana in 1996 to that in 1998?
Offer a terse response. 0.56. What is the ratio of the Imports (in Local Currency Unit) of Senegal in 1996 to that in 1998?
Keep it short and to the point. 0.84. What is the ratio of the Imports (in Local Currency Unit) of Syrian Arab Republic in 1996 to that in 1998?
Give a very brief answer. 1.08. What is the ratio of the Imports (in Local Currency Unit) in Vanuatu in 1996 to that in 1998?
Your answer should be compact. 0.83. What is the ratio of the Imports (in Local Currency Unit) in Ghana in 1996 to that in 1999?
Your answer should be compact. 0.45. What is the ratio of the Imports (in Local Currency Unit) in Senegal in 1996 to that in 1999?
Offer a terse response. 0.76. What is the ratio of the Imports (in Local Currency Unit) of Vanuatu in 1996 to that in 1999?
Keep it short and to the point. 0.78. What is the ratio of the Imports (in Local Currency Unit) in Ghana in 1997 to that in 1998?
Your answer should be very brief. 0.93. What is the ratio of the Imports (in Local Currency Unit) in Senegal in 1997 to that in 1998?
Offer a very short reply. 0.9. What is the ratio of the Imports (in Local Currency Unit) of Syrian Arab Republic in 1997 to that in 1998?
Your answer should be very brief. 1.03. What is the ratio of the Imports (in Local Currency Unit) of Vanuatu in 1997 to that in 1998?
Ensure brevity in your answer.  0.85. What is the ratio of the Imports (in Local Currency Unit) of Ghana in 1997 to that in 1999?
Your answer should be compact. 0.73. What is the ratio of the Imports (in Local Currency Unit) of Senegal in 1997 to that in 1999?
Ensure brevity in your answer.  0.82. What is the ratio of the Imports (in Local Currency Unit) in Syrian Arab Republic in 1997 to that in 1999?
Your answer should be compact. 0.96. What is the ratio of the Imports (in Local Currency Unit) of Vanuatu in 1997 to that in 1999?
Your answer should be very brief. 0.8. What is the ratio of the Imports (in Local Currency Unit) in Ghana in 1998 to that in 1999?
Keep it short and to the point. 0.79. What is the ratio of the Imports (in Local Currency Unit) of Senegal in 1998 to that in 1999?
Make the answer very short. 0.92. What is the ratio of the Imports (in Local Currency Unit) in Syrian Arab Republic in 1998 to that in 1999?
Give a very brief answer. 0.93. What is the ratio of the Imports (in Local Currency Unit) in Vanuatu in 1998 to that in 1999?
Offer a very short reply. 0.94. What is the difference between the highest and the second highest Imports (in Local Currency Unit) in Ghana?
Offer a very short reply. 2.13e+08. What is the difference between the highest and the second highest Imports (in Local Currency Unit) in Senegal?
Offer a terse response. 9.34e+1. What is the difference between the highest and the second highest Imports (in Local Currency Unit) of Syrian Arab Republic?
Provide a short and direct response. 1.09e+09. What is the difference between the highest and the second highest Imports (in Local Currency Unit) of Vanuatu?
Ensure brevity in your answer.  1.09e+09. What is the difference between the highest and the lowest Imports (in Local Currency Unit) in Ghana?
Provide a short and direct response. 8.80e+08. What is the difference between the highest and the lowest Imports (in Local Currency Unit) in Senegal?
Make the answer very short. 6.38e+11. What is the difference between the highest and the lowest Imports (in Local Currency Unit) in Syrian Arab Republic?
Provide a succinct answer. 9.39e+1. What is the difference between the highest and the lowest Imports (in Local Currency Unit) in Vanuatu?
Provide a short and direct response. 6.00e+09. 